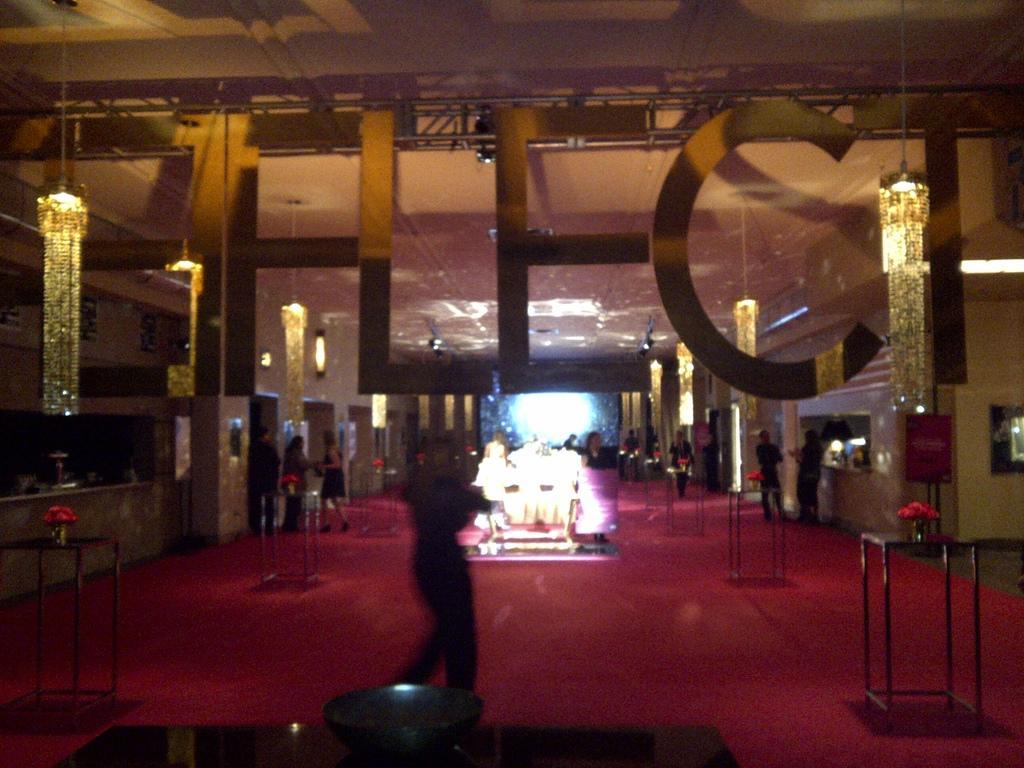Can you describe this image briefly? In this image, we can see few people, tables, flower vases and red surface. Background we can see wall, lights, few object, banners and ceiling. Here we can see some text. 